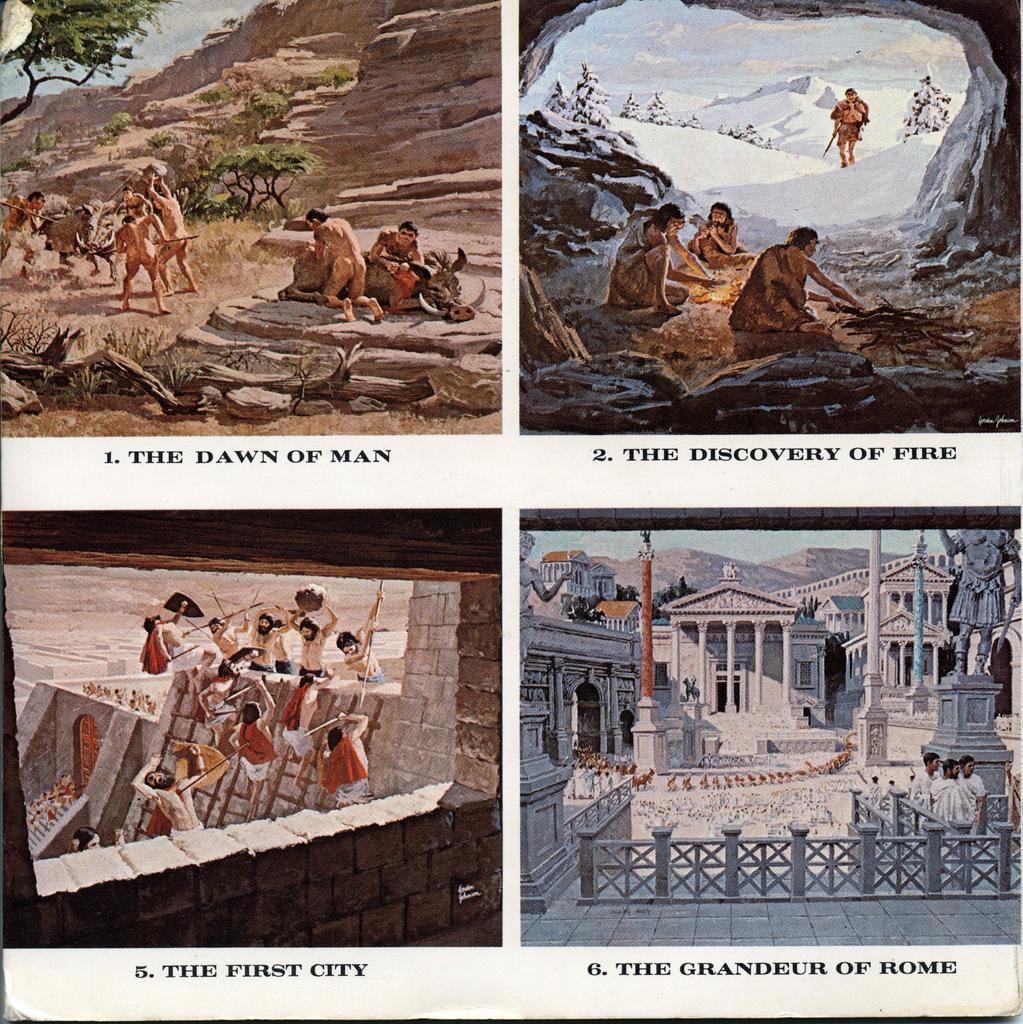How would you summarize this image in a sentence or two? In this image there are many pictures. In the top left there is a image. There are people on the rocks. There are trees in the image. In the top right there are people sitting on the ground. There is snow on the ground. In between them there is bonfire. In the bottom right there are buildings. There are people standing. In the bottom left there are people climbing a wall. Below every picture there is text on the image. 